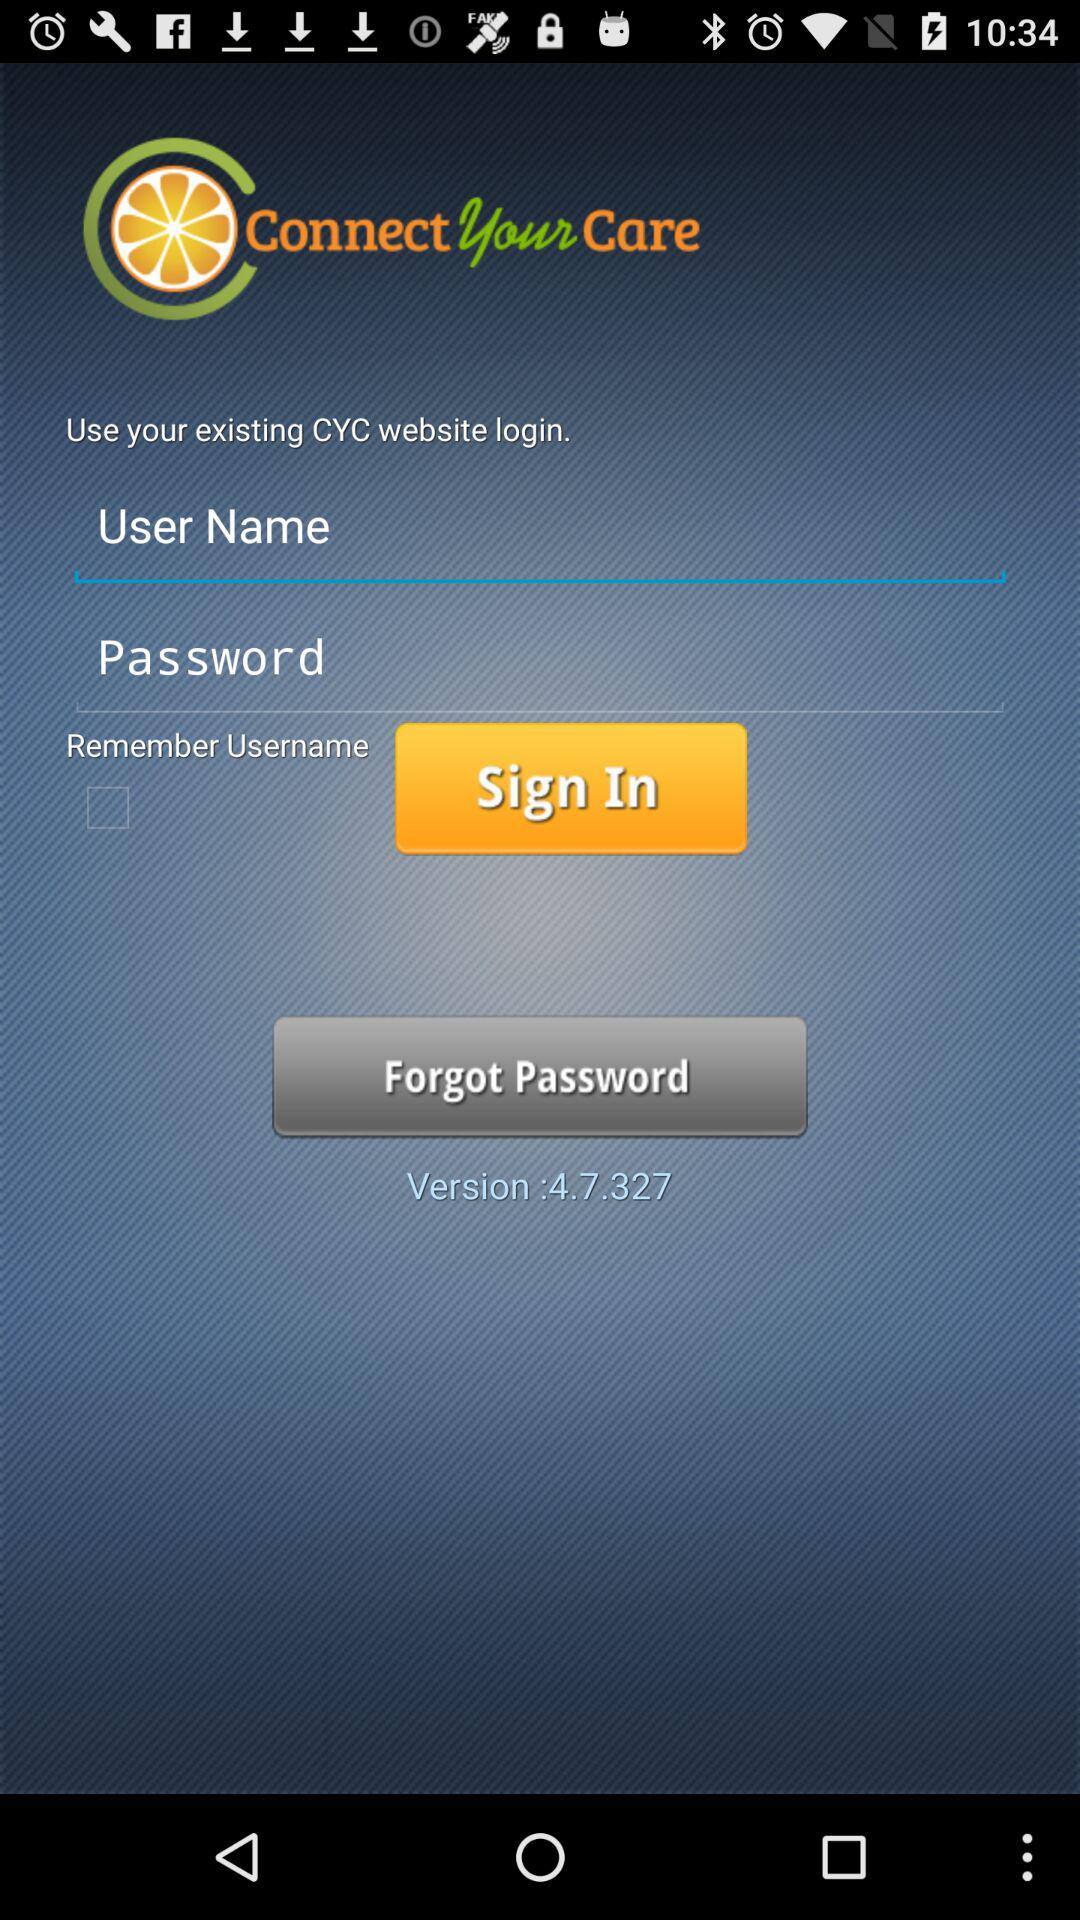What existing accounts can be used for login? The existing account that can be used for login is "CYC website". 